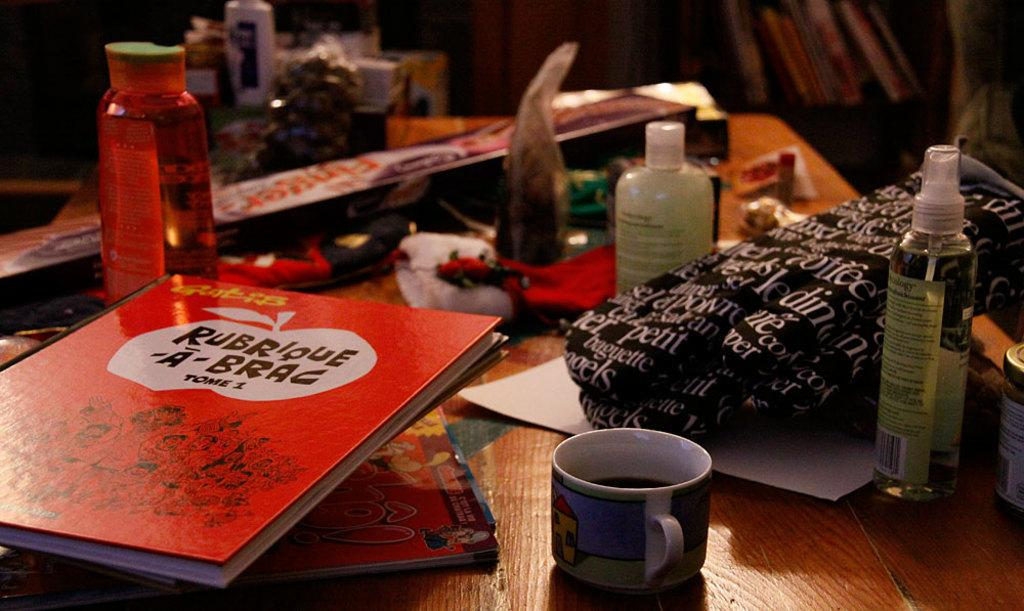What type of containers are visible in the image? There are bottles and a cup in the image. What else can be seen in the image besides containers? There are books in the image. How does the vegetable in the image twist and turn? There is no vegetable present in the image; it only contains bottles, a cup, and books. 